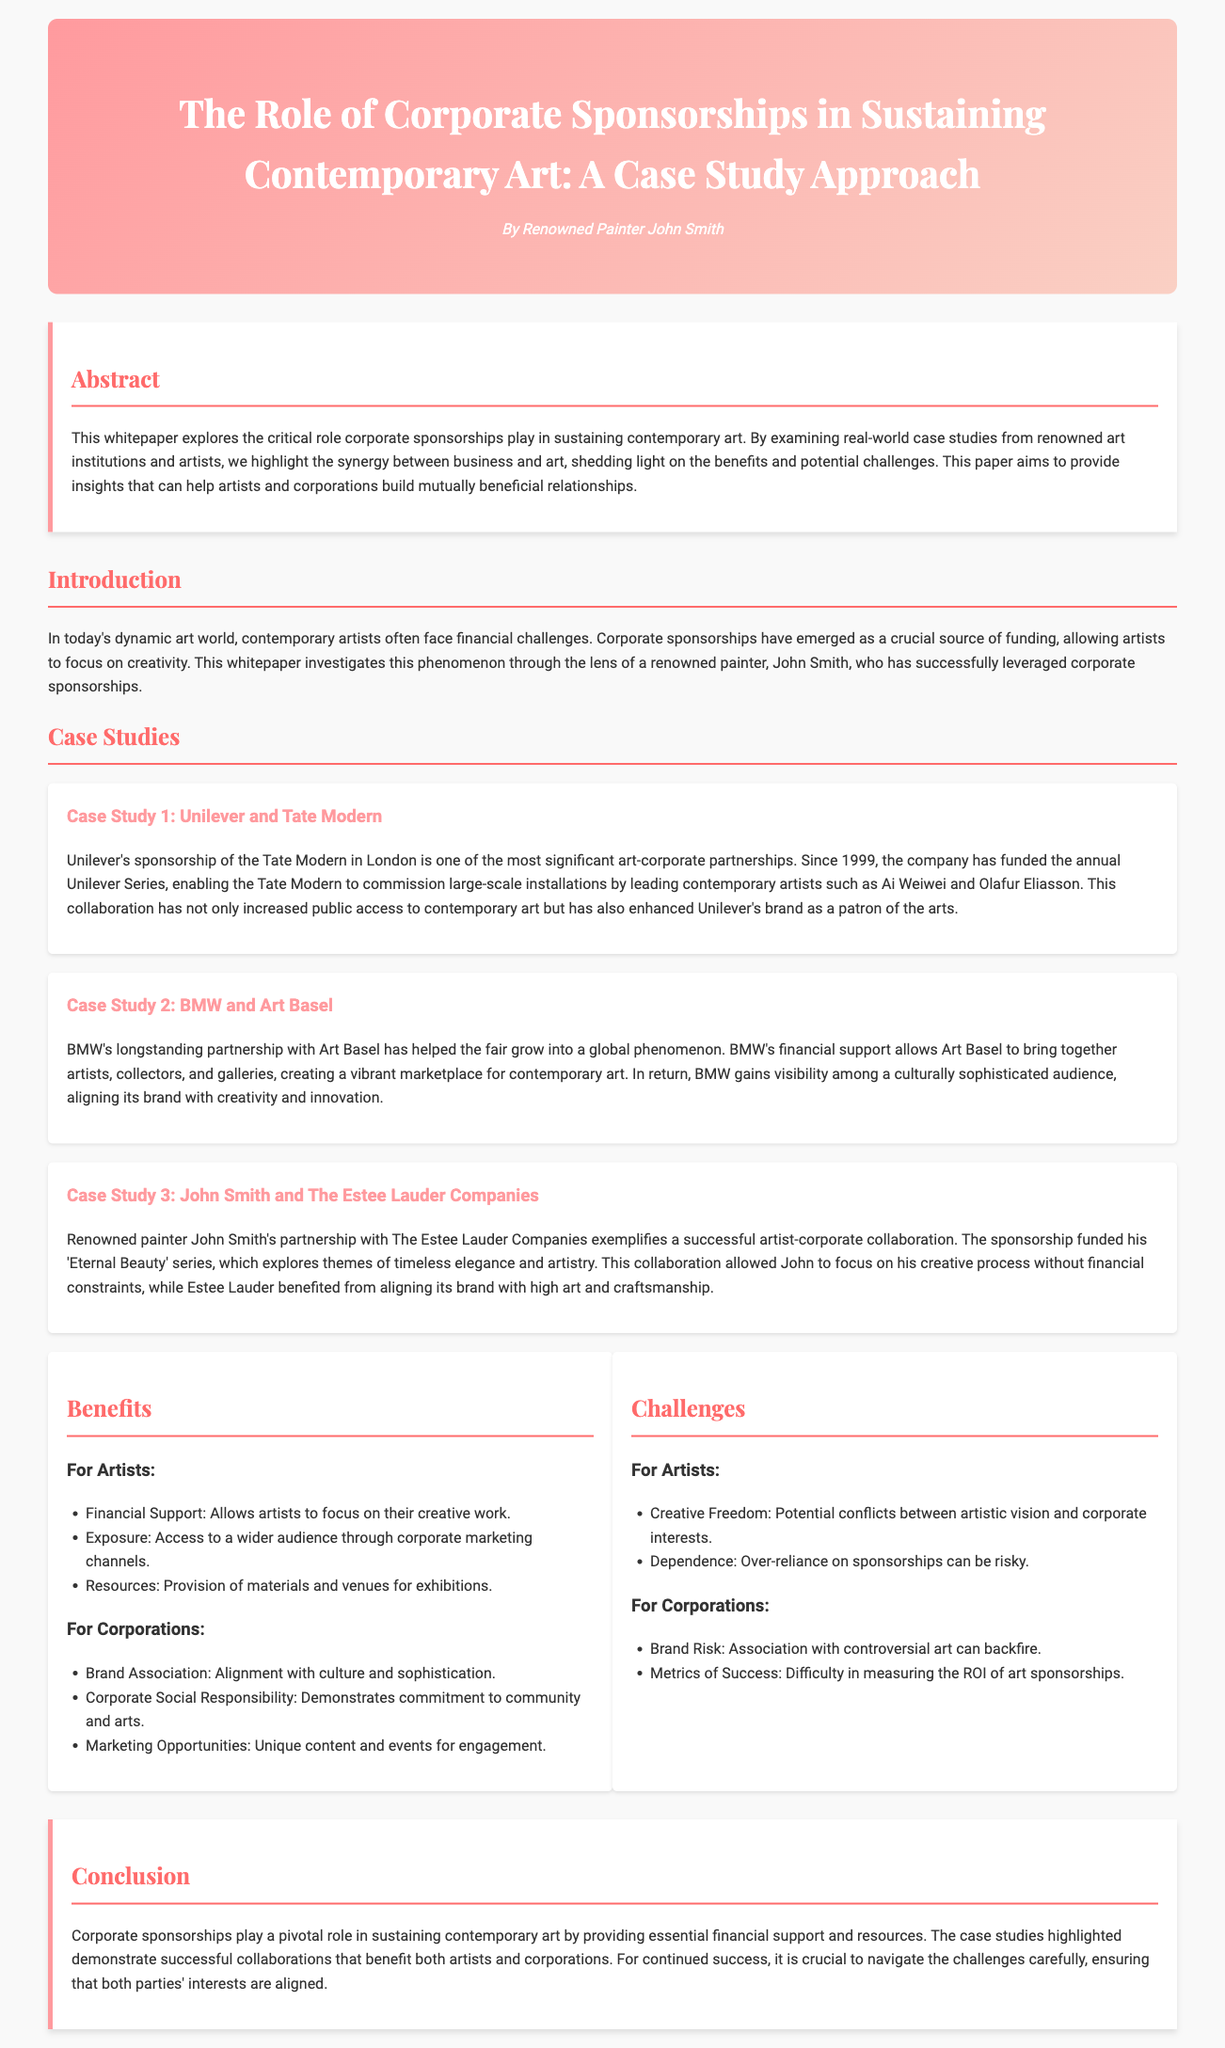What is the title of the whitepaper? The title of the whitepaper is found in the header section, which highlights the main topic discussed.
Answer: The Role of Corporate Sponsorships in Sustaining Contemporary Art: A Case Study Approach Who is the author of the whitepaper? The author of the whitepaper is mentioned right below the title in the header section.
Answer: John Smith When did Unilever start sponsoring Tate Modern? The document states the start year of the sponsorship in the case study section about Unilever.
Answer: 1999 What is one benefit for artists mentioned in the whitepaper? The benefits for artists are listed under the Benefits section, highlighting positive aspects of corporate sponsorship.
Answer: Financial Support What potential conflict is mentioned for artists related to corporate sponsorships? The challenges for artists are also outlined in the document, identifying issues that could arise in sponsorships.
Answer: Creative Freedom What is a key metric for corporations to consider regarding sponsorships? The challenges for corporations include aspects that measure the success of their sponsorship efforts.
Answer: Metrics of Success How many case studies are presented in the document? The number of case studies is clear from the section where they are introduced, indicating how many examples are provided.
Answer: Three What year did BMW establish its partnership with Art Basel? The partnership duration is implied in the context of its long-standing nature but not a specific year is provided in the document.
Answer: Not specified What is the primary role of corporate sponsorships in the art world according to the conclusion? The conclusion summarizes the main purpose of sponsorships as discussed throughout the paper.
Answer: Financial support 